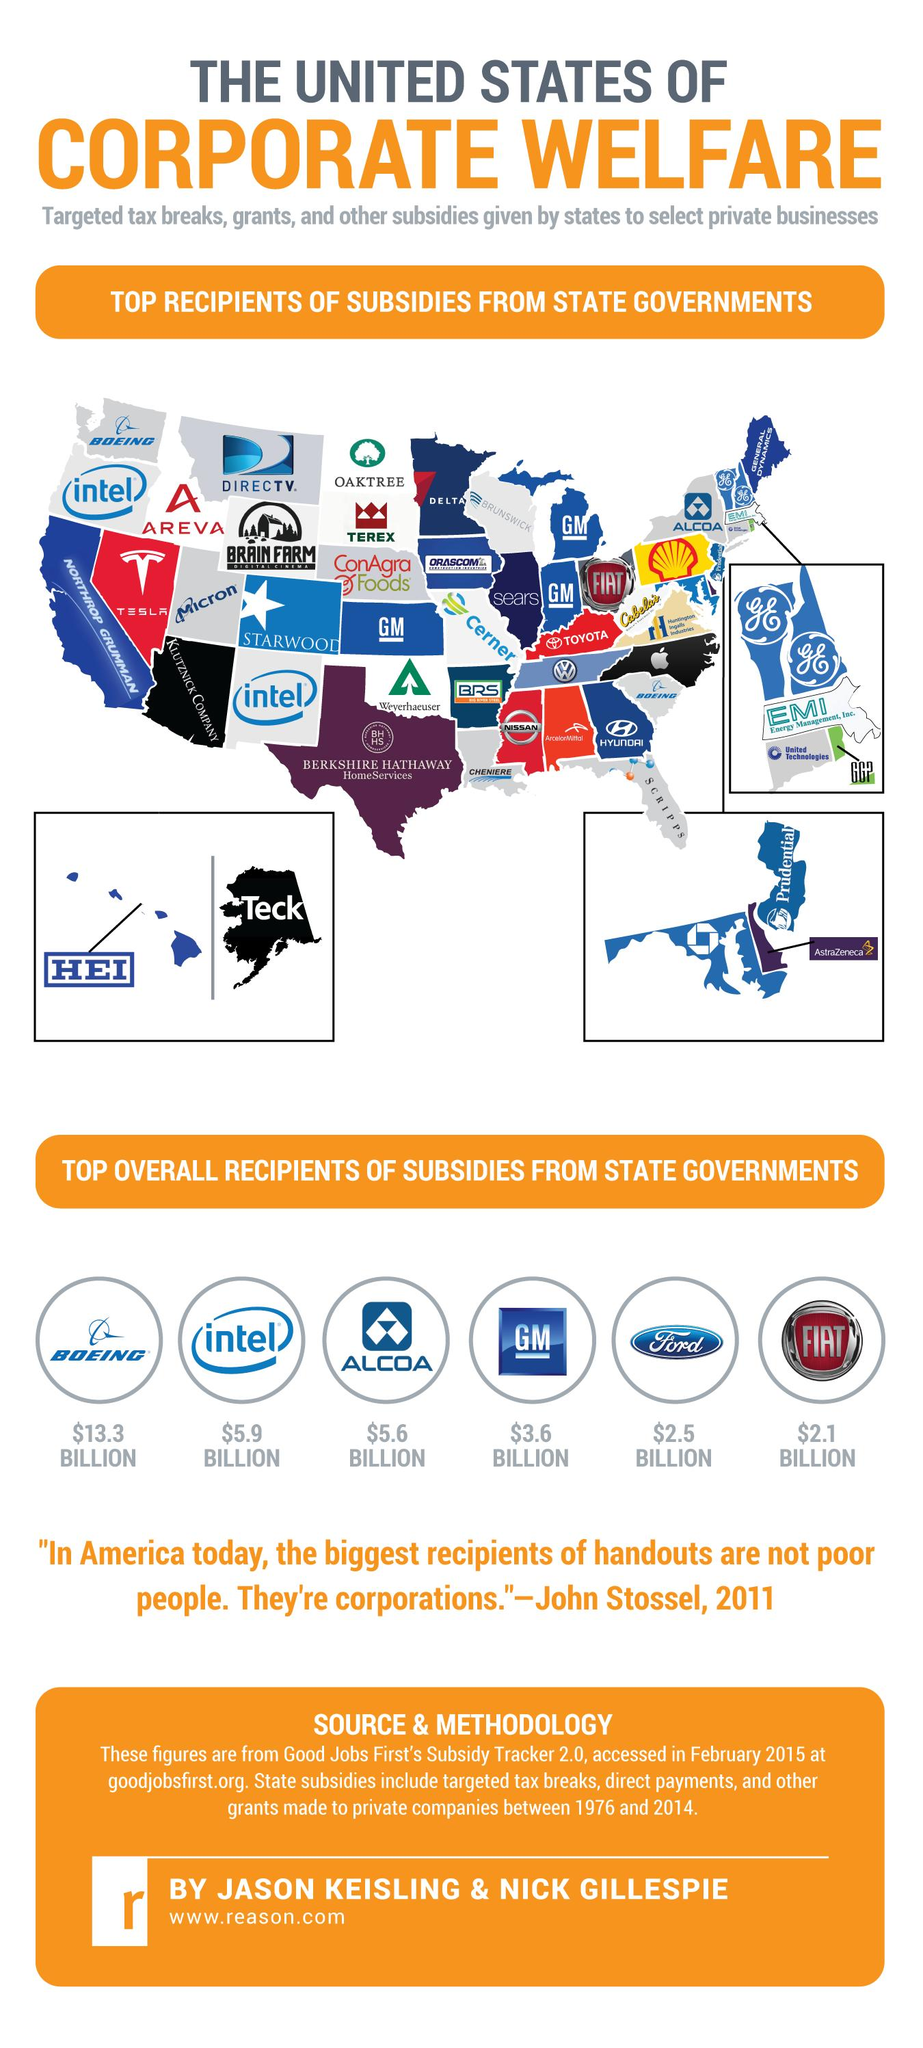Highlight a few significant elements in this photo. Many successful businesses have received subsidies from state governments, with six of them being among the top. The corporation that has received the highest subsidy is $13.3 BILLION. 